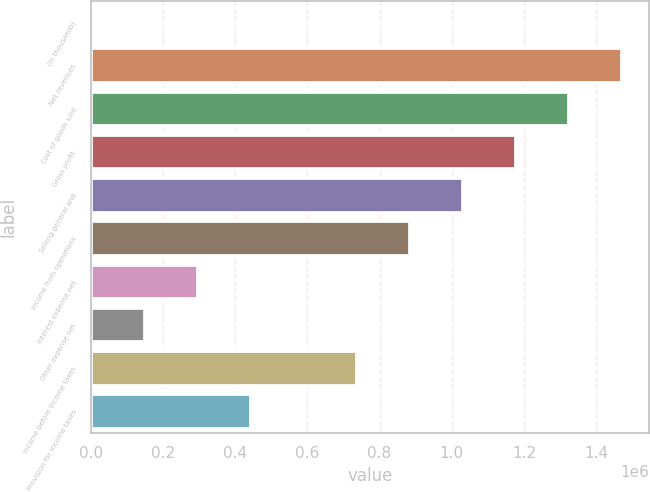<chart> <loc_0><loc_0><loc_500><loc_500><bar_chart><fcel>(In thousands)<fcel>Net revenues<fcel>Cost of goods sold<fcel>Gross profit<fcel>Selling general and<fcel>Income from operations<fcel>Interest expense net<fcel>Other expense net<fcel>Income before income taxes<fcel>Provision for income taxes<nl><fcel>2011<fcel>1.47268e+06<fcel>1.32562e+06<fcel>1.17855e+06<fcel>1.03148e+06<fcel>884415<fcel>296146<fcel>149078<fcel>737348<fcel>443213<nl></chart> 